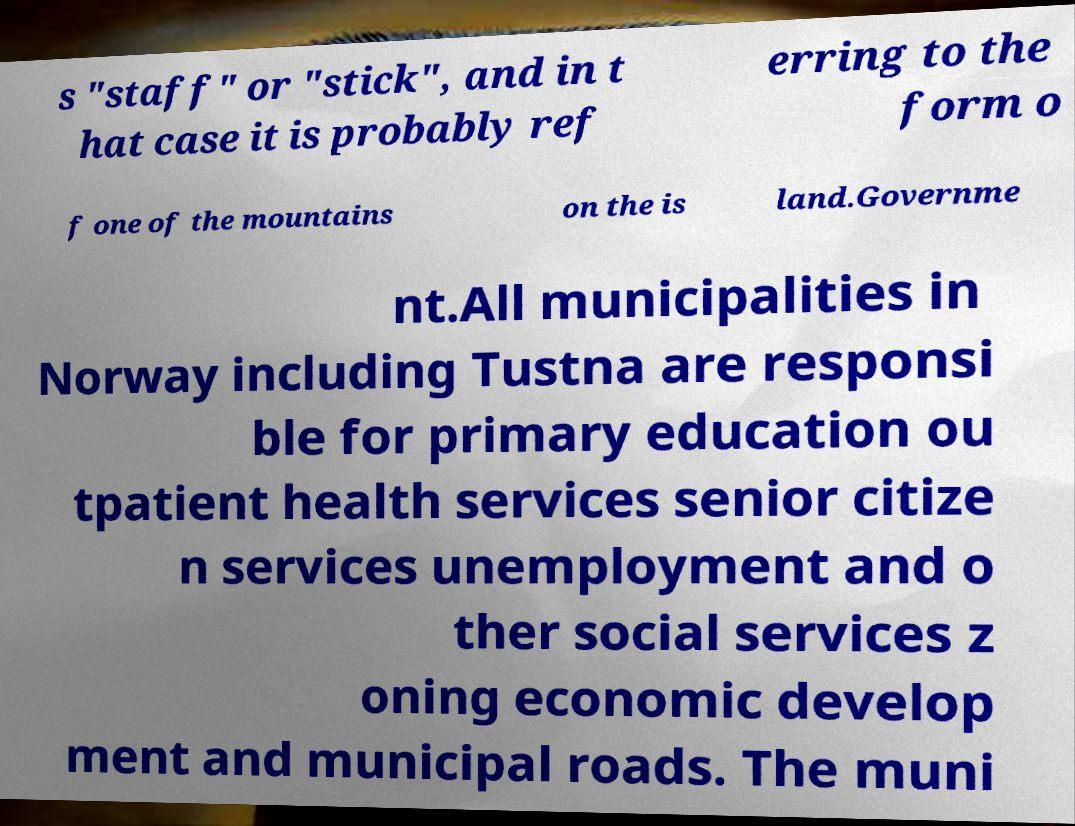Can you accurately transcribe the text from the provided image for me? s "staff" or "stick", and in t hat case it is probably ref erring to the form o f one of the mountains on the is land.Governme nt.All municipalities in Norway including Tustna are responsi ble for primary education ou tpatient health services senior citize n services unemployment and o ther social services z oning economic develop ment and municipal roads. The muni 